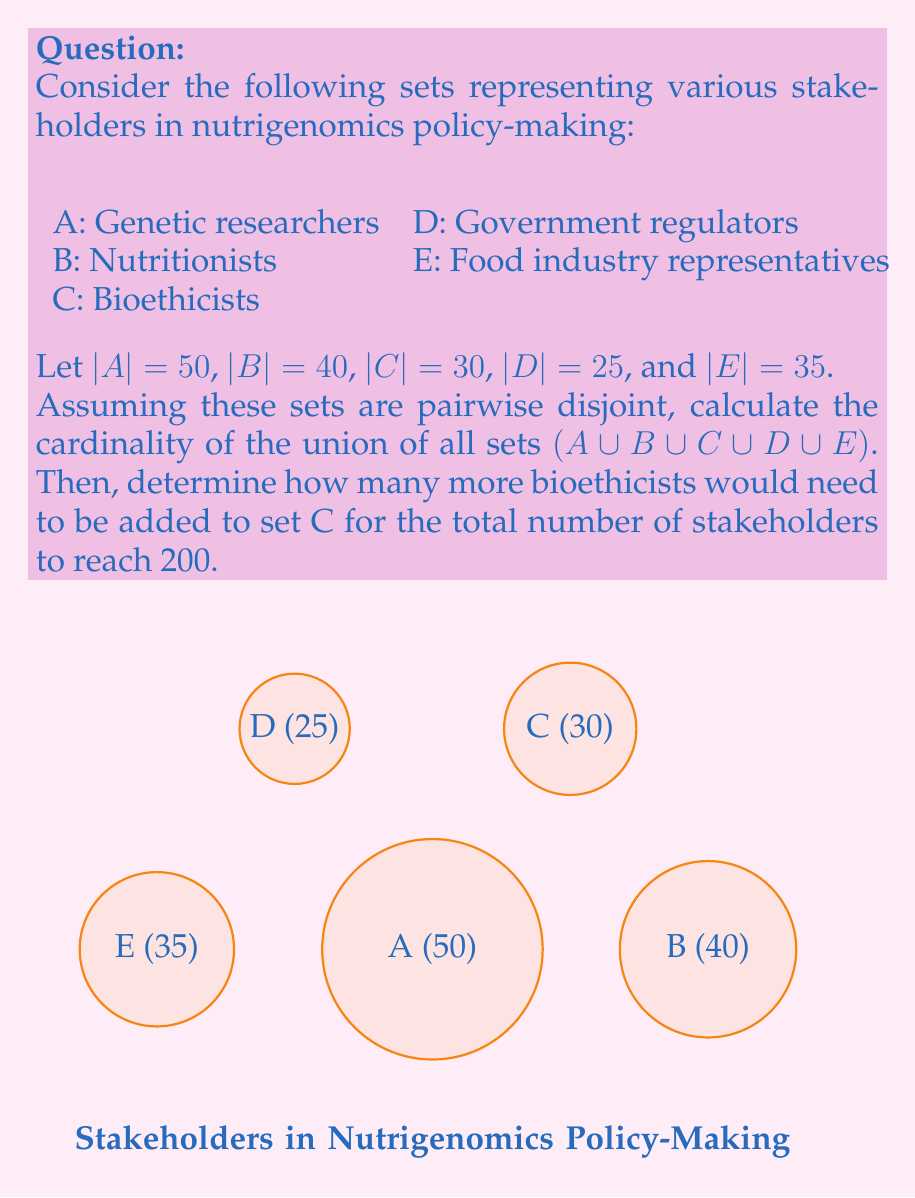Help me with this question. Let's approach this problem step-by-step:

1) First, we need to calculate the cardinality of the union of all sets. Since the sets are pairwise disjoint, we can simply add their individual cardinalities:

   $|A \cup B \cup C \cup D \cup E| = |A| + |B| + |C| + |D| + |E|$

2) Substituting the given values:

   $|A \cup B \cup C \cup D \cup E| = 50 + 40 + 30 + 25 + 35 = 180$

3) Now, we need to determine how many more bioethicists (set C) are needed to reach a total of 200 stakeholders. Let's call this number $x$.

4) We can set up an equation:

   $180 + x = 200$

5) Solving for $x$:

   $x = 200 - 180 = 20$

Therefore, 20 more bioethicists would need to be added to set C for the total number of stakeholders to reach 200.
Answer: 20 bioethicists 